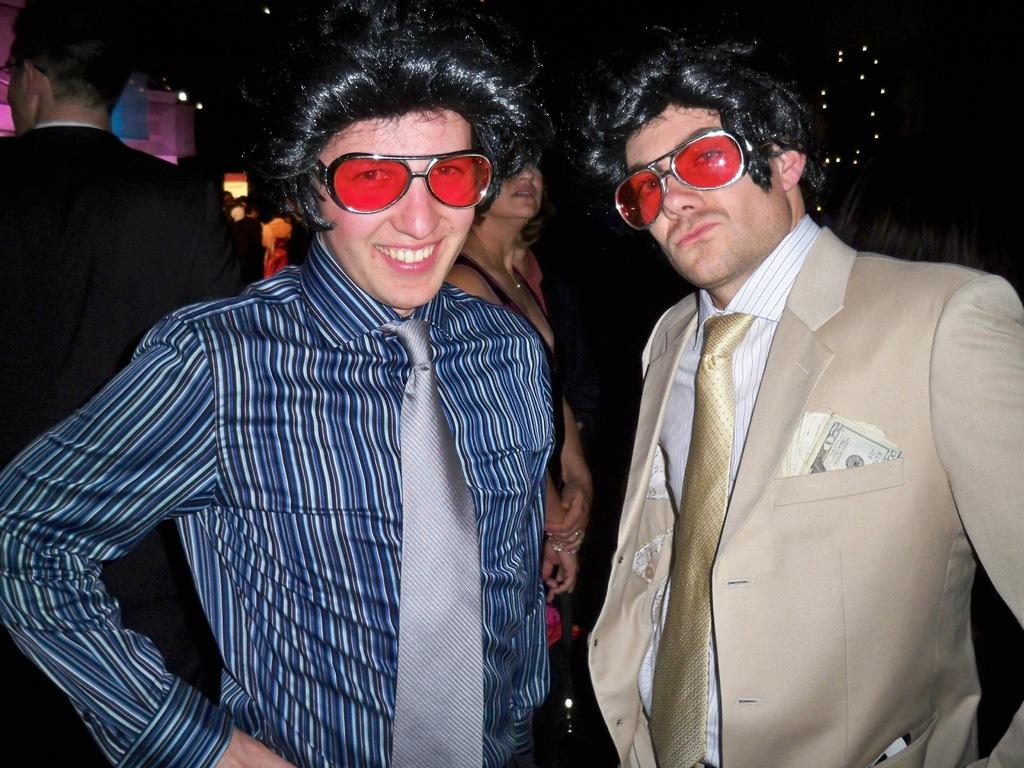How many people are in the image? There are two persons in the image. What are the persons doing in the image? The persons are standing. What accessories are the persons wearing in the image? The persons are wearing goggles and wigs. What type of wind can be seen blowing in the image? There is no wind visible in the image. What occupation might the persons be associated with in the image? There is no indication of the persons' occupations in the image. 